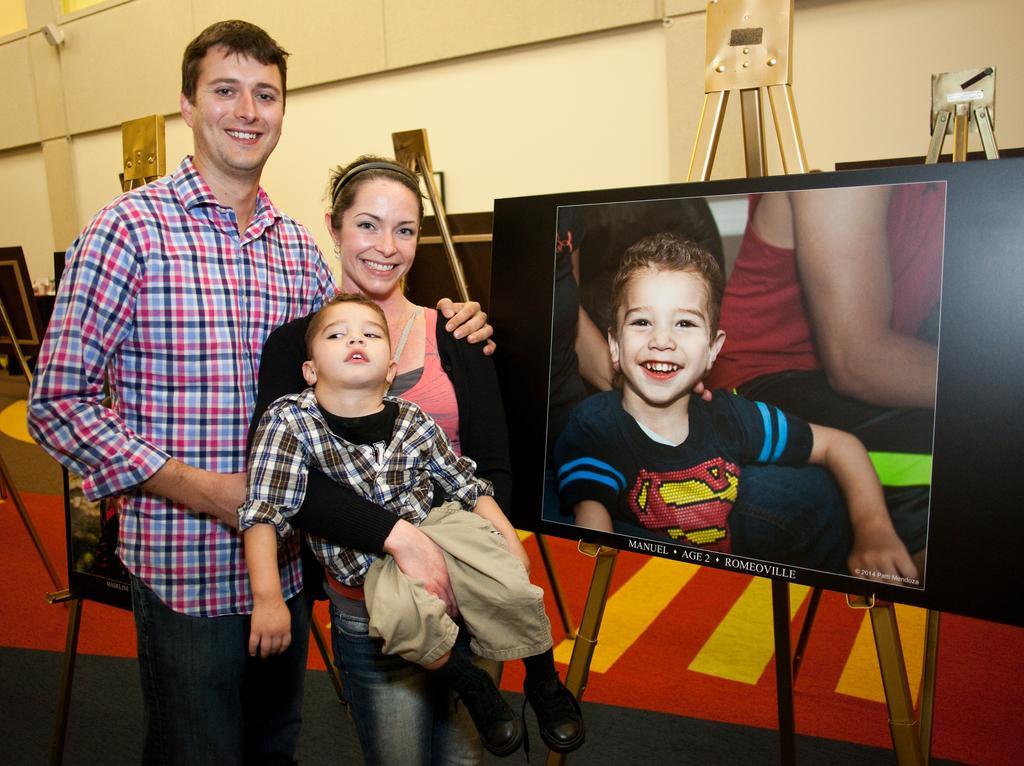Describe this image in one or two sentences. In this image we can see one big wall, some objects are on the wall, one woman standing and holding a boy. There are some stands, some boards near to the wall, one photo on the black board, some text on the board and one man standing near the stand. 